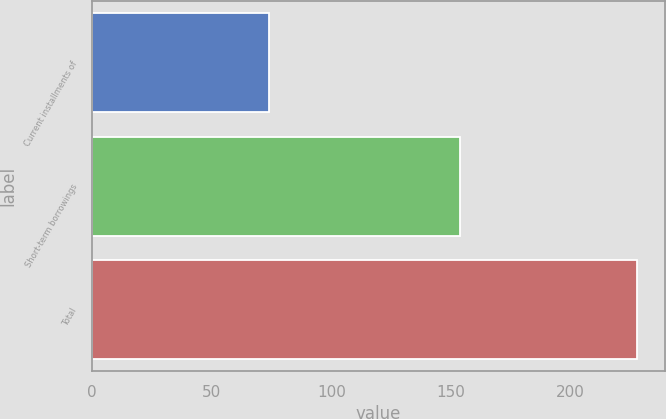<chart> <loc_0><loc_0><loc_500><loc_500><bar_chart><fcel>Current installments of<fcel>Short-term borrowings<fcel>Total<nl><fcel>74<fcel>154<fcel>228<nl></chart> 